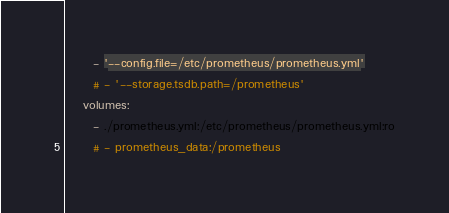<code> <loc_0><loc_0><loc_500><loc_500><_YAML_>      - '--config.file=/etc/prometheus/prometheus.yml'
      # - '--storage.tsdb.path=/prometheus'
    volumes:
      - ./prometheus.yml:/etc/prometheus/prometheus.yml:ro
      # - prometheus_data:/prometheus

</code> 